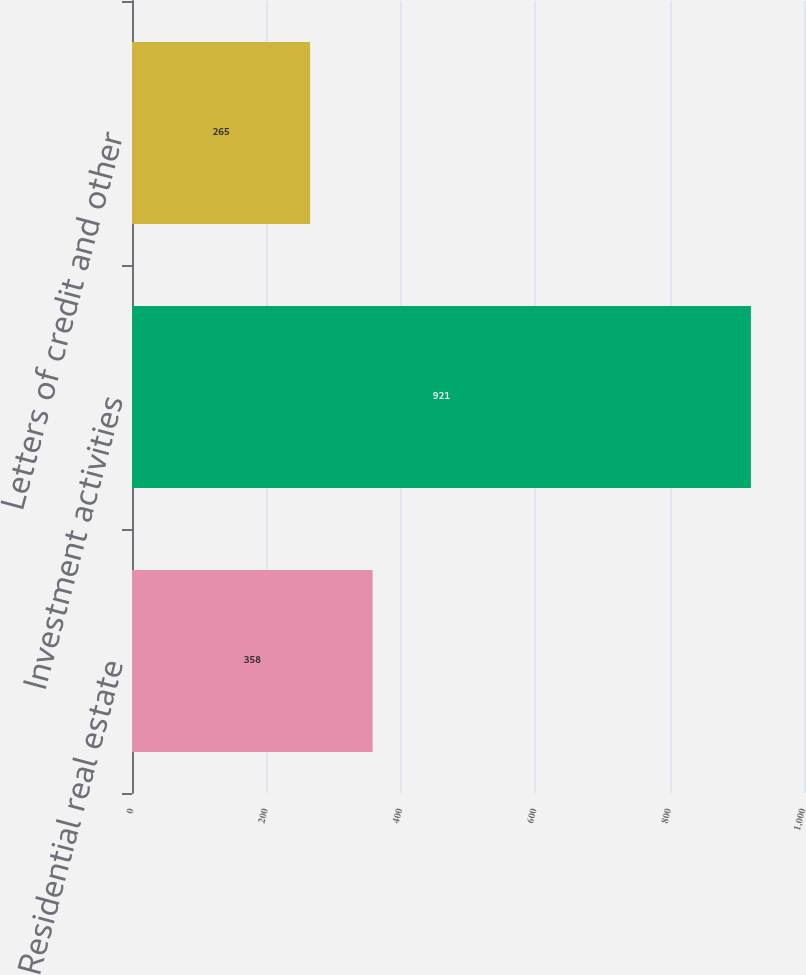Convert chart. <chart><loc_0><loc_0><loc_500><loc_500><bar_chart><fcel>Residential real estate<fcel>Investment activities<fcel>Letters of credit and other<nl><fcel>358<fcel>921<fcel>265<nl></chart> 